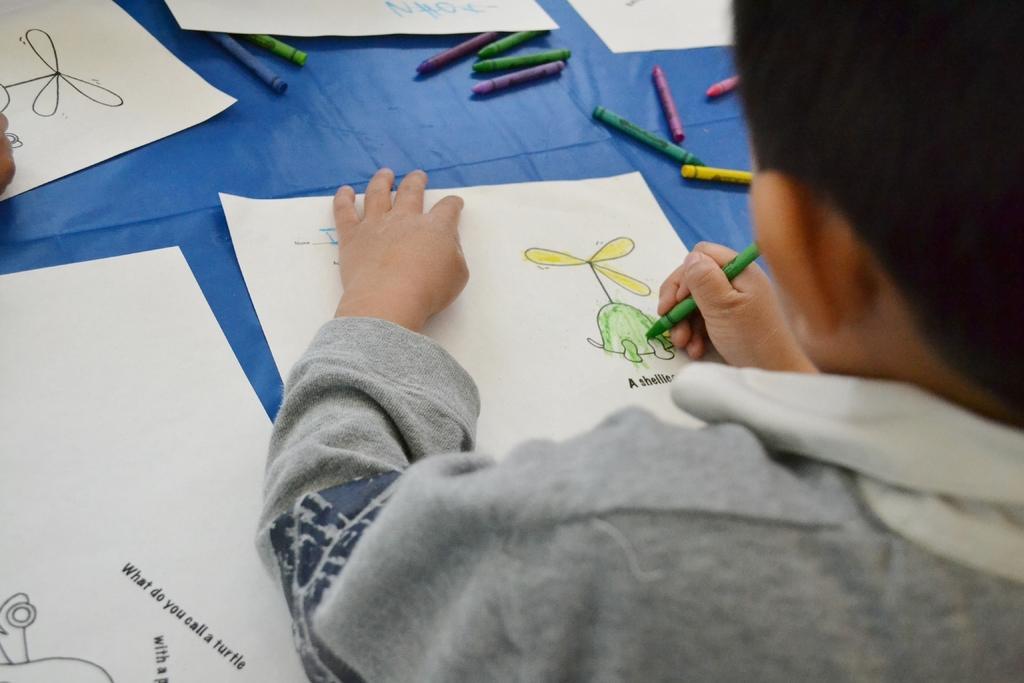How would you summarize this image in a sentence or two? In the image we can see a child wearing clothes and the child is holding a crayon color in hand. In front of the child there are many white paper sheets and different colors of crayons. 